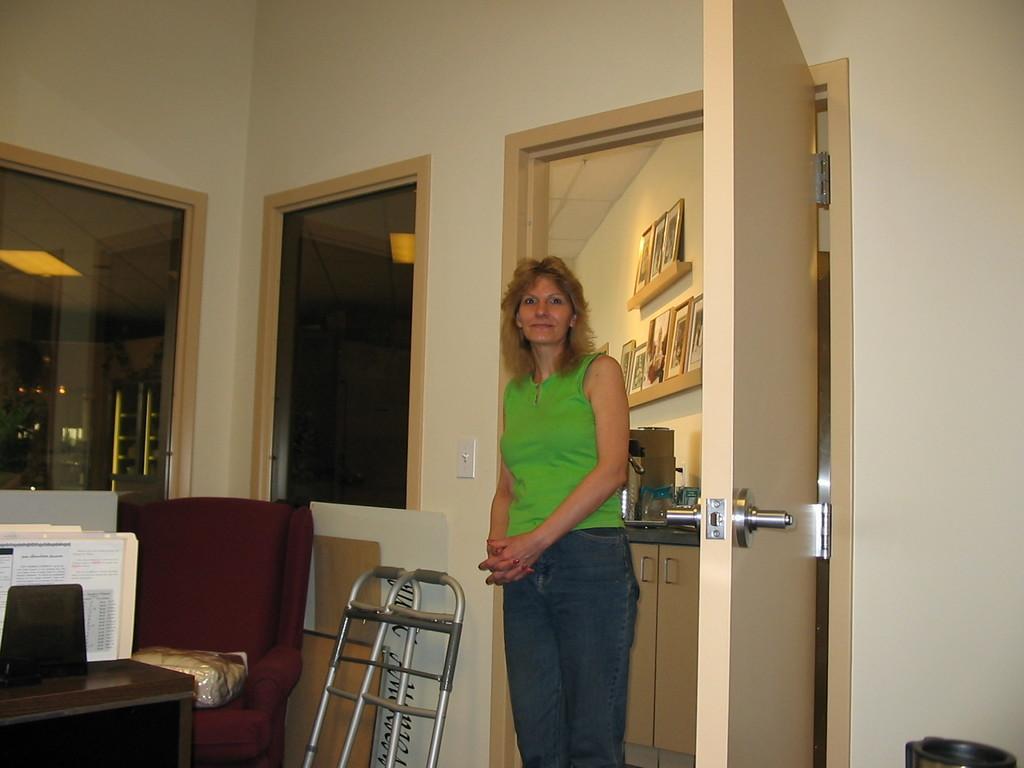Describe this image in one or two sentences. In this picture there is a woman wearing green t-shirt and blue jeans standing and looking into the camera and giving a pose. Behind there is a white wall glass window. On the left side there is a sofa, table and silver small ladder. In the background there is a wall with many photo frames and door. 